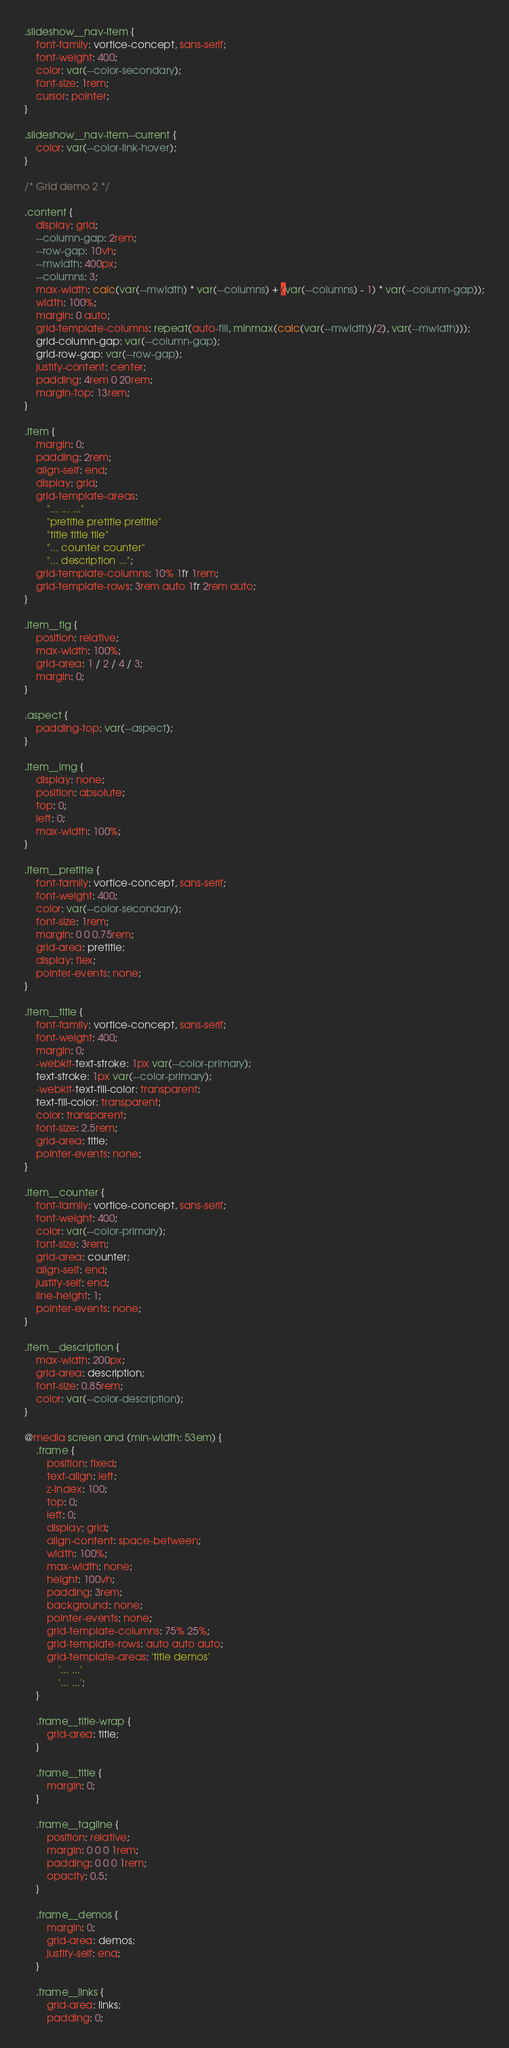<code> <loc_0><loc_0><loc_500><loc_500><_CSS_>
.slideshow__nav-item {
    font-family: vortice-concept, sans-serif;
    font-weight: 400;
    color: var(--color-secondary);
    font-size: 1rem;
    cursor: pointer;
}

.slideshow__nav-item--current {
	color: var(--color-link-hover);
}

/* Grid demo 2 */

.content {
    display: grid;
    --column-gap: 2rem;
    --row-gap: 10vh;
    --mwidth: 400px;
    --columns: 3;
    max-width: calc(var(--mwidth) * var(--columns) + (var(--columns) - 1) * var(--column-gap));
    width: 100%;
    margin: 0 auto;
    grid-template-columns: repeat(auto-fill, minmax(calc(var(--mwidth)/2), var(--mwidth)));
    grid-column-gap: var(--column-gap);
    grid-row-gap: var(--row-gap);
    justify-content: center;
    padding: 4rem 0 20rem;
    margin-top: 13rem;
}

.item {
    margin: 0;
    padding: 2rem;
    align-self: end;
    display: grid;
    grid-template-areas:
        "... ... ..."
        "pretitle pretitle pretitle"
        "title title tile"
        "... counter counter"
        "... description ...";
    grid-template-columns: 10% 1fr 1rem;
    grid-template-rows: 3rem auto 1fr 2rem auto;
}

.item__fig {
    position: relative;
    max-width: 100%;
    grid-area: 1 / 2 / 4 / 3;
    margin: 0;
}

.aspect {
    padding-top: var(--aspect);
}

.item__img {
    display: none;
    position: absolute;
    top: 0;
    left: 0;
    max-width: 100%;
}

.item__pretitle {
    font-family: vortice-concept, sans-serif;
    font-weight: 400;
    color: var(--color-secondary);
    font-size: 1rem;
    margin: 0 0 0.75rem;
    grid-area: pretitle;
    display: flex;
    pointer-events: none;
}

.item__title {
    font-family: vortice-concept, sans-serif;
    font-weight: 400;
    margin: 0;
    -webkit-text-stroke: 1px var(--color-primary);
    text-stroke: 1px var(--color-primary);
    -webkit-text-fill-color: transparent;
    text-fill-color: transparent;
    color: transparent;
    font-size: 2.5rem;
    grid-area: title;
    pointer-events: none;
}

.item__counter {
    font-family: vortice-concept, sans-serif;
    font-weight: 400;
    color: var(--color-primary);
    font-size: 3rem;
    grid-area: counter;
    align-self: end;
    justify-self: end;
    line-height: 1;
    pointer-events: none;
}

.item__description {
    max-width: 200px;
    grid-area: description;
    font-size: 0.85rem;
    color: var(--color-description);
}

@media screen and (min-width: 53em) {
    .frame {
        position: fixed;
        text-align: left;
        z-index: 100;
        top: 0;
        left: 0;
        display: grid;
        align-content: space-between;
        width: 100%;
        max-width: none;
        height: 100vh;
        padding: 3rem;
        background: none;
        pointer-events: none;
        grid-template-columns: 75% 25%;
        grid-template-rows: auto auto auto;
        grid-template-areas: 'title demos'
            '... ...'
            '... ...';
    }

    .frame__title-wrap {
        grid-area: title;
    }

    .frame__title {
        margin: 0;
    }

    .frame__tagline {
        position: relative;
        margin: 0 0 0 1rem;
        padding: 0 0 0 1rem;
        opacity: 0.5;
    }

    .frame__demos {
        margin: 0;
        grid-area: demos;
        justify-self: end;
    }

    .frame__links {
        grid-area: links;
        padding: 0;</code> 